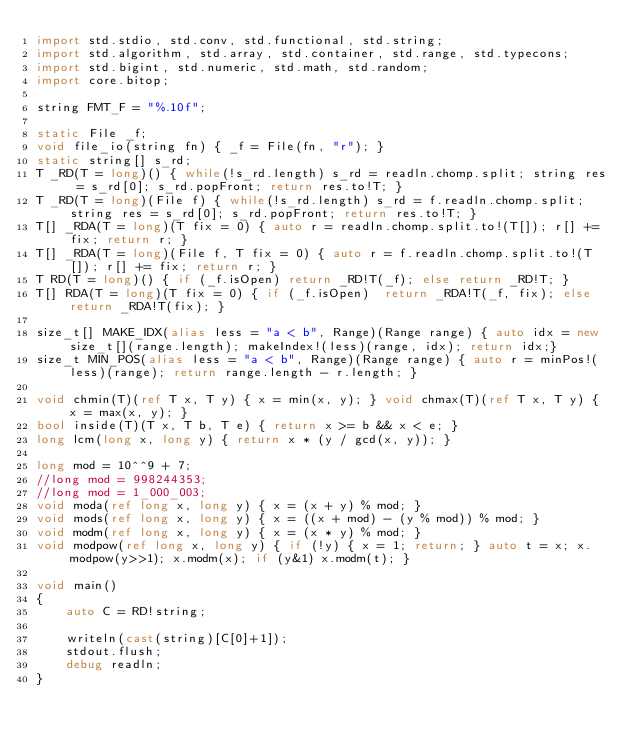<code> <loc_0><loc_0><loc_500><loc_500><_D_>import std.stdio, std.conv, std.functional, std.string;
import std.algorithm, std.array, std.container, std.range, std.typecons;
import std.bigint, std.numeric, std.math, std.random;
import core.bitop;

string FMT_F = "%.10f";

static File _f;
void file_io(string fn) { _f = File(fn, "r"); }
static string[] s_rd;
T _RD(T = long)() { while(!s_rd.length) s_rd = readln.chomp.split; string res = s_rd[0]; s_rd.popFront; return res.to!T; }
T _RD(T = long)(File f) { while(!s_rd.length) s_rd = f.readln.chomp.split; string res = s_rd[0]; s_rd.popFront; return res.to!T; }
T[] _RDA(T = long)(T fix = 0) { auto r = readln.chomp.split.to!(T[]); r[] += fix; return r; }
T[] _RDA(T = long)(File f, T fix = 0) { auto r = f.readln.chomp.split.to!(T[]); r[] += fix; return r; }
T RD(T = long)() { if (_f.isOpen) return _RD!T(_f); else return _RD!T; }
T[] RDA(T = long)(T fix = 0) { if (_f.isOpen)  return _RDA!T(_f, fix); else return _RDA!T(fix); }

size_t[] MAKE_IDX(alias less = "a < b", Range)(Range range) { auto idx = new size_t[](range.length); makeIndex!(less)(range, idx); return idx;}
size_t MIN_POS(alias less = "a < b", Range)(Range range) { auto r = minPos!(less)(range); return range.length - r.length; }

void chmin(T)(ref T x, T y) { x = min(x, y); } void chmax(T)(ref T x, T y) { x = max(x, y); }
bool inside(T)(T x, T b, T e) { return x >= b && x < e; }
long lcm(long x, long y) { return x * (y / gcd(x, y)); }

long mod = 10^^9 + 7;
//long mod = 998244353;
//long mod = 1_000_003;
void moda(ref long x, long y) { x = (x + y) % mod; }
void mods(ref long x, long y) { x = ((x + mod) - (y % mod)) % mod; }
void modm(ref long x, long y) { x = (x * y) % mod; }
void modpow(ref long x, long y) { if (!y) { x = 1; return; } auto t = x; x.modpow(y>>1); x.modm(x); if (y&1) x.modm(t); }

void main()
{
	auto C = RD!string;

	writeln(cast(string)[C[0]+1]);
	stdout.flush;
	debug readln;
}
</code> 